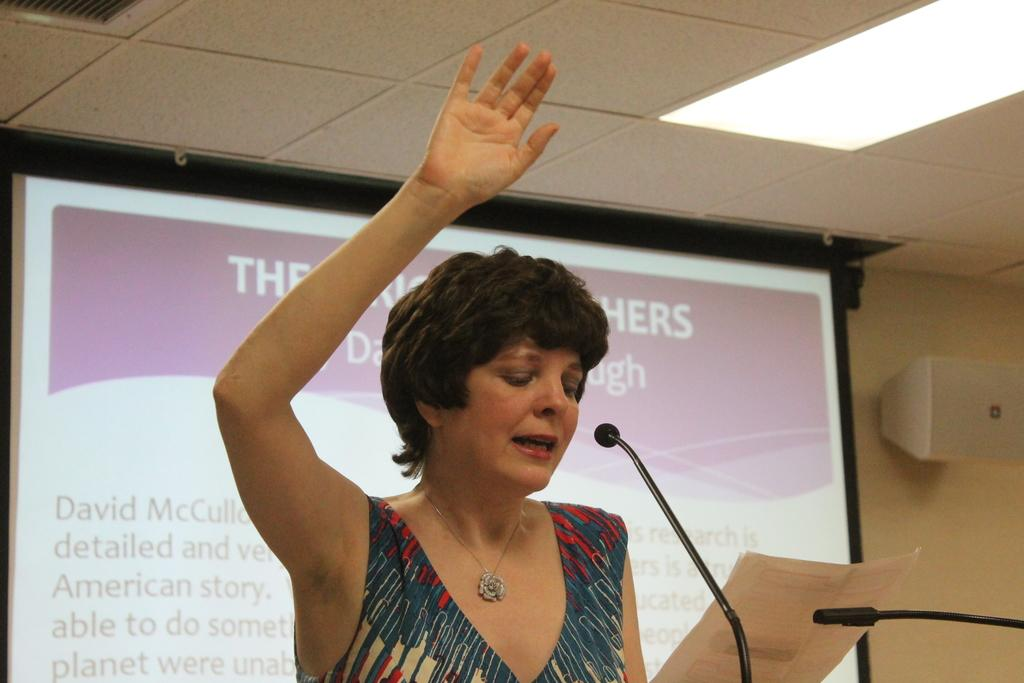Who is the main subject in the image? There is a woman in the image. What is the woman holding in the image? The woman is holding a paper. Where is the woman positioned in the image? The woman is standing in front of microphones. What can be seen in the background of the image? There is a screen, a light, and a speaker visible in the background of the image. Is the woman in danger of falling into quicksand in the image? There is no quicksand present in the image, so the woman is not in danger of falling into it. 